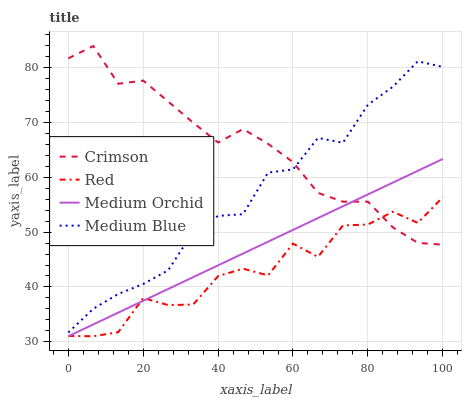Does Red have the minimum area under the curve?
Answer yes or no. Yes. Does Crimson have the maximum area under the curve?
Answer yes or no. Yes. Does Medium Orchid have the minimum area under the curve?
Answer yes or no. No. Does Medium Orchid have the maximum area under the curve?
Answer yes or no. No. Is Medium Orchid the smoothest?
Answer yes or no. Yes. Is Red the roughest?
Answer yes or no. Yes. Is Medium Blue the smoothest?
Answer yes or no. No. Is Medium Blue the roughest?
Answer yes or no. No. Does Medium Blue have the lowest value?
Answer yes or no. No. Does Crimson have the highest value?
Answer yes or no. Yes. Does Medium Orchid have the highest value?
Answer yes or no. No. Is Medium Orchid less than Medium Blue?
Answer yes or no. Yes. Is Medium Blue greater than Medium Orchid?
Answer yes or no. Yes. Does Medium Orchid intersect Crimson?
Answer yes or no. Yes. Is Medium Orchid less than Crimson?
Answer yes or no. No. Is Medium Orchid greater than Crimson?
Answer yes or no. No. Does Medium Orchid intersect Medium Blue?
Answer yes or no. No. 